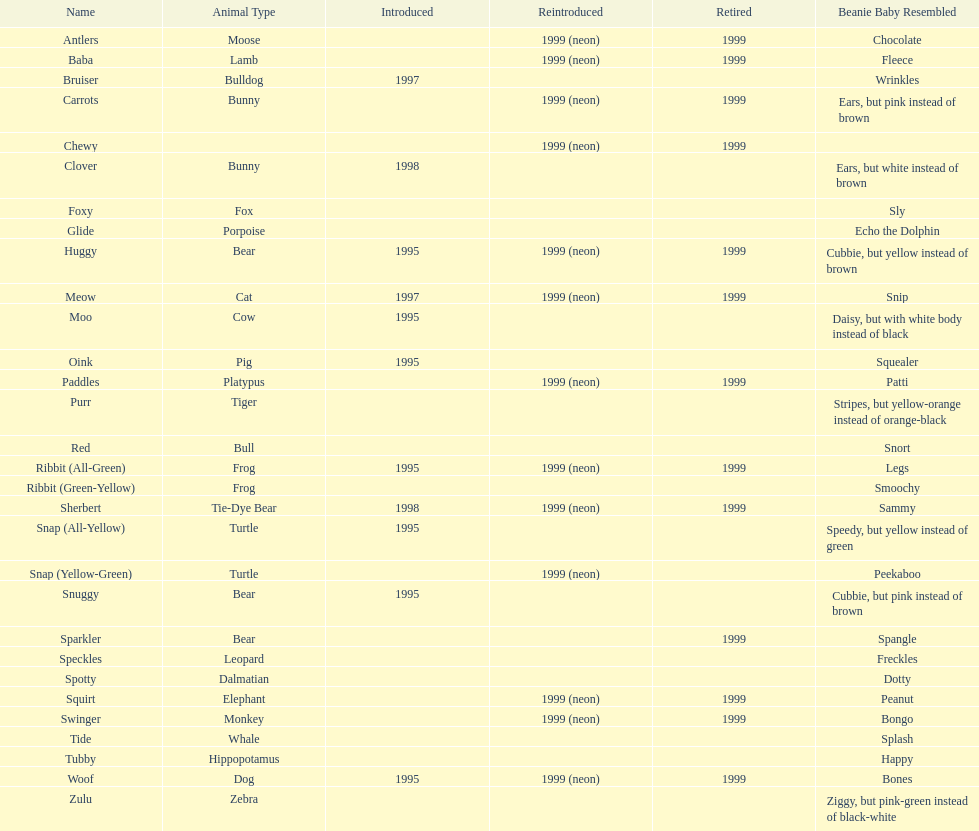What is the quantity of frog cushion friends? 2. 